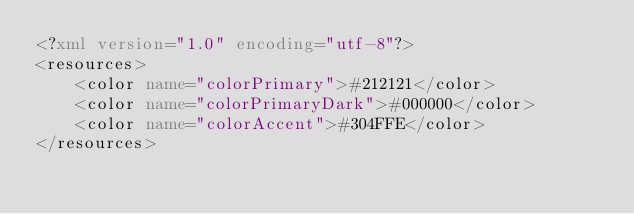Convert code to text. <code><loc_0><loc_0><loc_500><loc_500><_XML_><?xml version="1.0" encoding="utf-8"?>
<resources>
    <color name="colorPrimary">#212121</color>
    <color name="colorPrimaryDark">#000000</color>
    <color name="colorAccent">#304FFE</color>
</resources>
</code> 